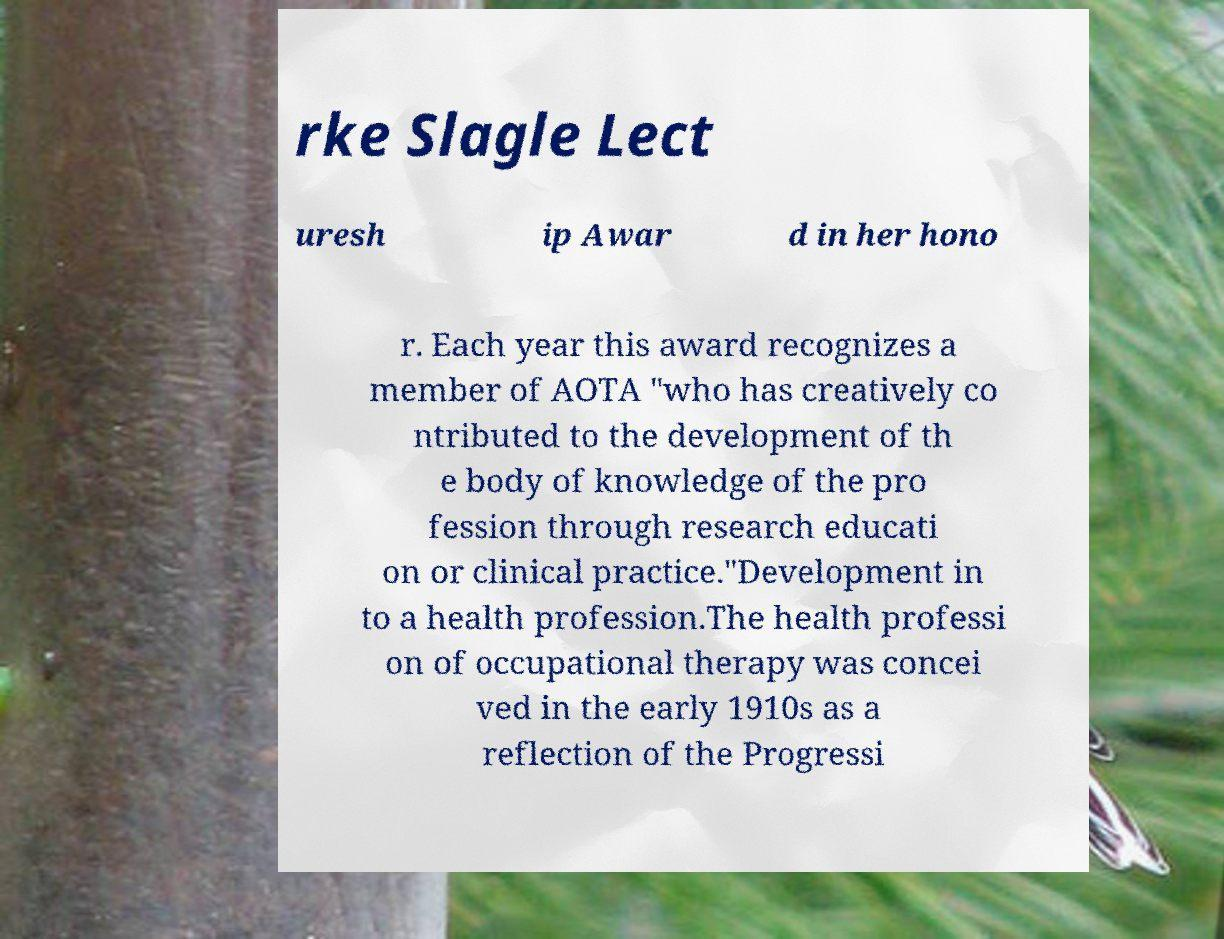I need the written content from this picture converted into text. Can you do that? rke Slagle Lect uresh ip Awar d in her hono r. Each year this award recognizes a member of AOTA "who has creatively co ntributed to the development of th e body of knowledge of the pro fession through research educati on or clinical practice."Development in to a health profession.The health professi on of occupational therapy was concei ved in the early 1910s as a reflection of the Progressi 